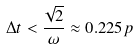<formula> <loc_0><loc_0><loc_500><loc_500>\Delta t < \frac { \sqrt { 2 } } { \omega } \approx 0 . 2 2 5 p</formula> 